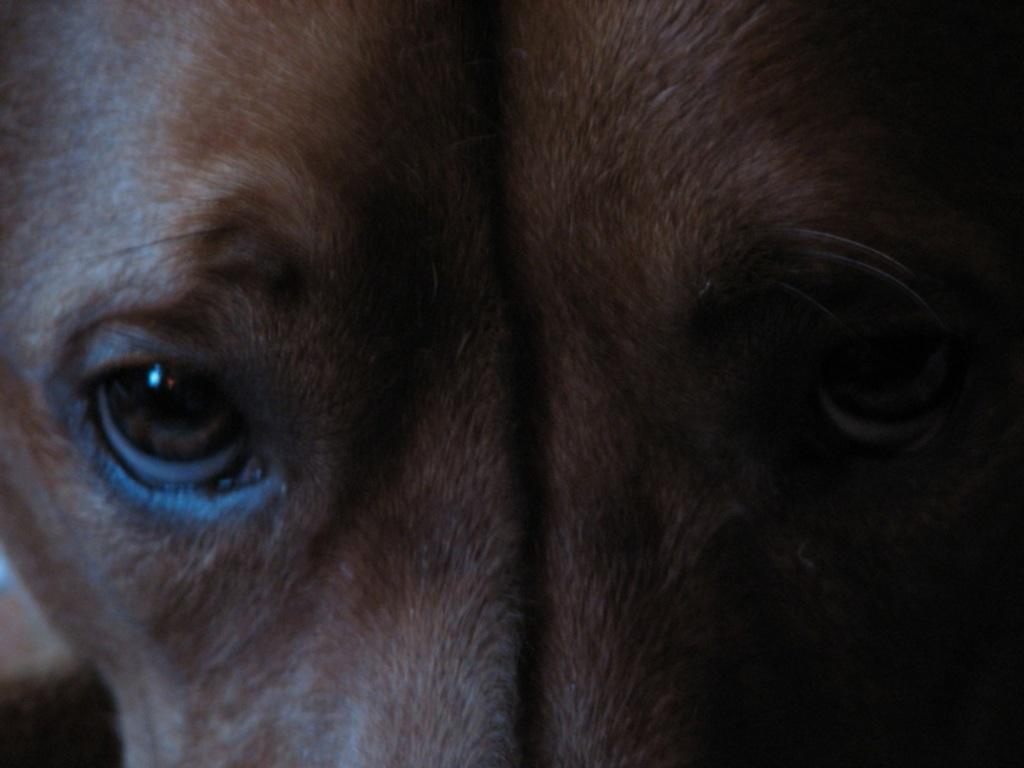What type of animal is in the image? There is a black animal in the image. Can you describe the animal's facial features? The animal has two eyes. What is the color of the background in the image? The background of the image is dark. What is the name of the pet in the image? There is no information about the animal being a pet, nor is there any indication of a name in the image. 